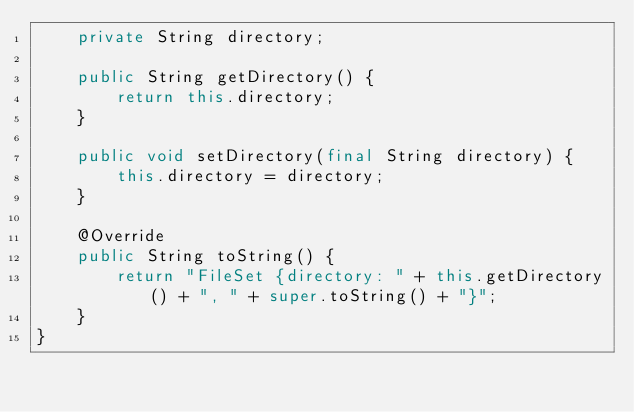Convert code to text. <code><loc_0><loc_0><loc_500><loc_500><_Java_>    private String directory;
    
    public String getDirectory() {
        return this.directory;
    }
    
    public void setDirectory(final String directory) {
        this.directory = directory;
    }
    
    @Override
    public String toString() {
        return "FileSet {directory: " + this.getDirectory() + ", " + super.toString() + "}";
    }
}
</code> 